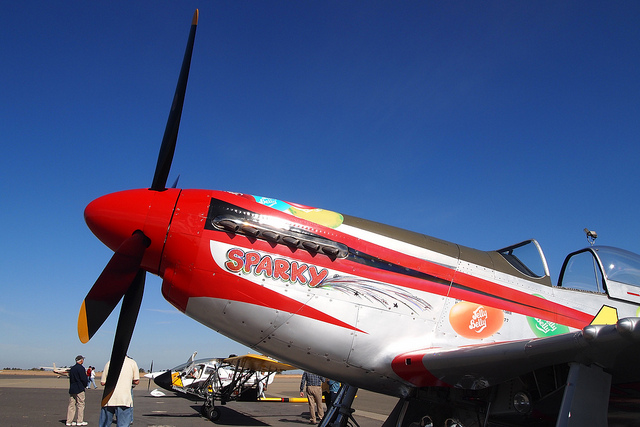Read all the text in this image. SPARKY Belly 